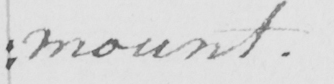Transcribe the text shown in this historical manuscript line. : mount . 